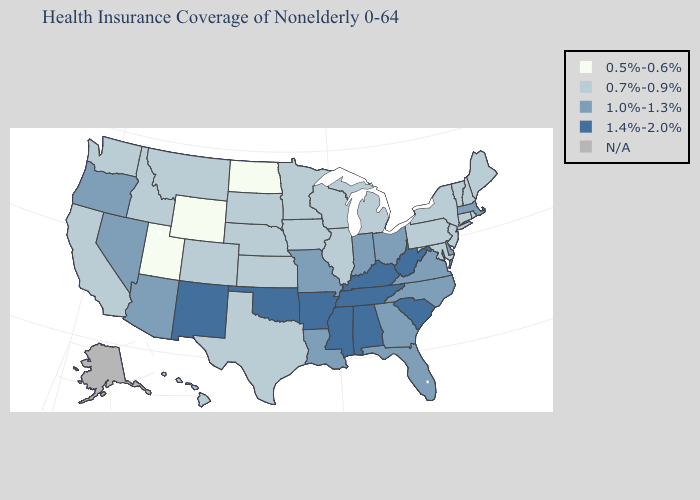What is the lowest value in the USA?
Give a very brief answer. 0.5%-0.6%. Name the states that have a value in the range 0.5%-0.6%?
Keep it brief. North Dakota, Utah, Wyoming. What is the highest value in states that border Kentucky?
Answer briefly. 1.4%-2.0%. Does the map have missing data?
Be succinct. Yes. Name the states that have a value in the range N/A?
Quick response, please. Alaska. Name the states that have a value in the range 0.5%-0.6%?
Keep it brief. North Dakota, Utah, Wyoming. Which states have the highest value in the USA?
Short answer required. Alabama, Arkansas, Kentucky, Mississippi, New Mexico, Oklahoma, South Carolina, Tennessee, West Virginia. What is the value of Tennessee?
Give a very brief answer. 1.4%-2.0%. Which states hav the highest value in the Northeast?
Be succinct. Massachusetts. Name the states that have a value in the range N/A?
Short answer required. Alaska. What is the value of Michigan?
Keep it brief. 0.7%-0.9%. Which states have the lowest value in the USA?
Be succinct. North Dakota, Utah, Wyoming. Which states have the lowest value in the USA?
Short answer required. North Dakota, Utah, Wyoming. Among the states that border Texas , which have the highest value?
Quick response, please. Arkansas, New Mexico, Oklahoma. 